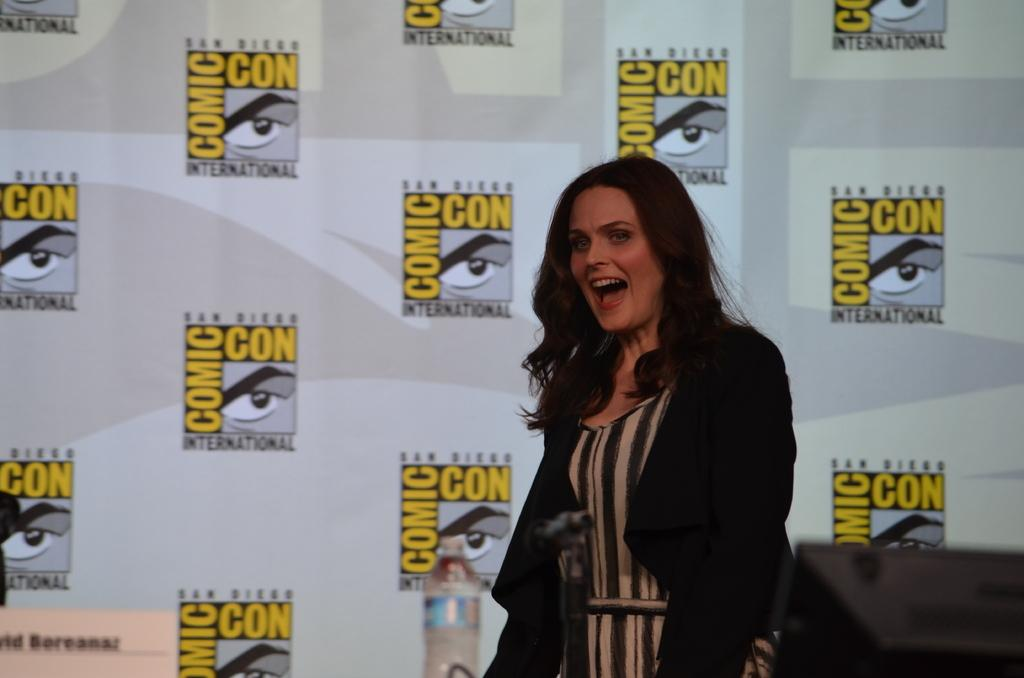Who is present in the image? There is a woman in the image. What object is visible at the bottom of the image? There is a microphone with a mic stand at the bottom of the image. What can be seen in the image besides the woman and the microphone? There is a bottle in the image. What can be seen in the background of the image? There is a wall with logos in the background of the image, and something is written on the wall. What type of plough is being used to cultivate the land in the image? There is no plough present in the image; it features a woman, a microphone, a bottle, and a wall with logos and writing. 